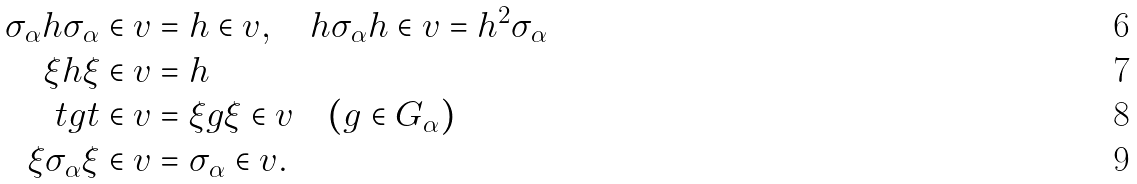Convert formula to latex. <formula><loc_0><loc_0><loc_500><loc_500>\sigma _ { \alpha } h \sigma _ { \alpha } \in v & = h \in v , \quad h \sigma _ { \alpha } h \in v = h ^ { 2 } \sigma _ { \alpha } \\ \xi h \xi \in v & = h \\ t g t \in v & = \xi g \xi \in v \quad ( g \in G _ { \alpha } ) \\ \xi \sigma _ { \alpha } \xi \in v & = \sigma _ { \alpha } \in v .</formula> 